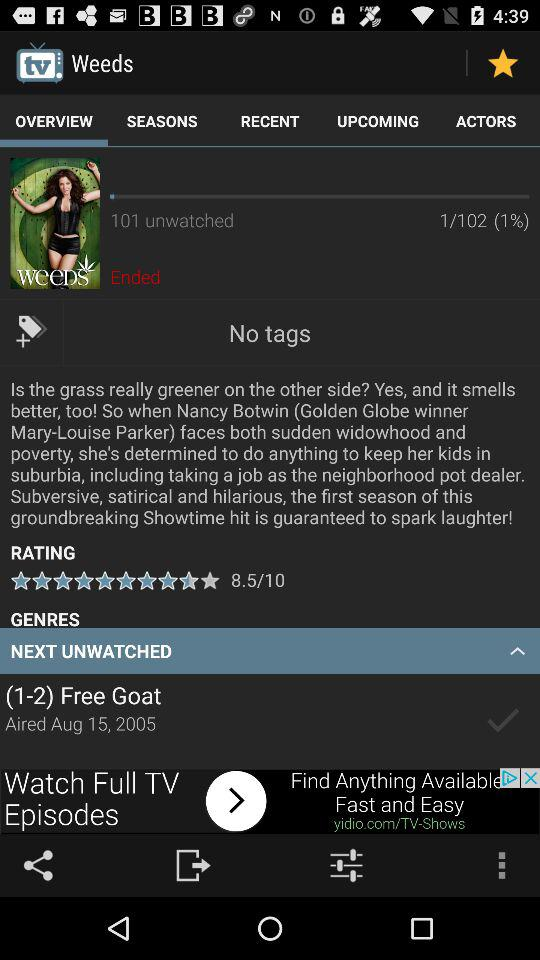What are the ratings? The rating is 8.5. 